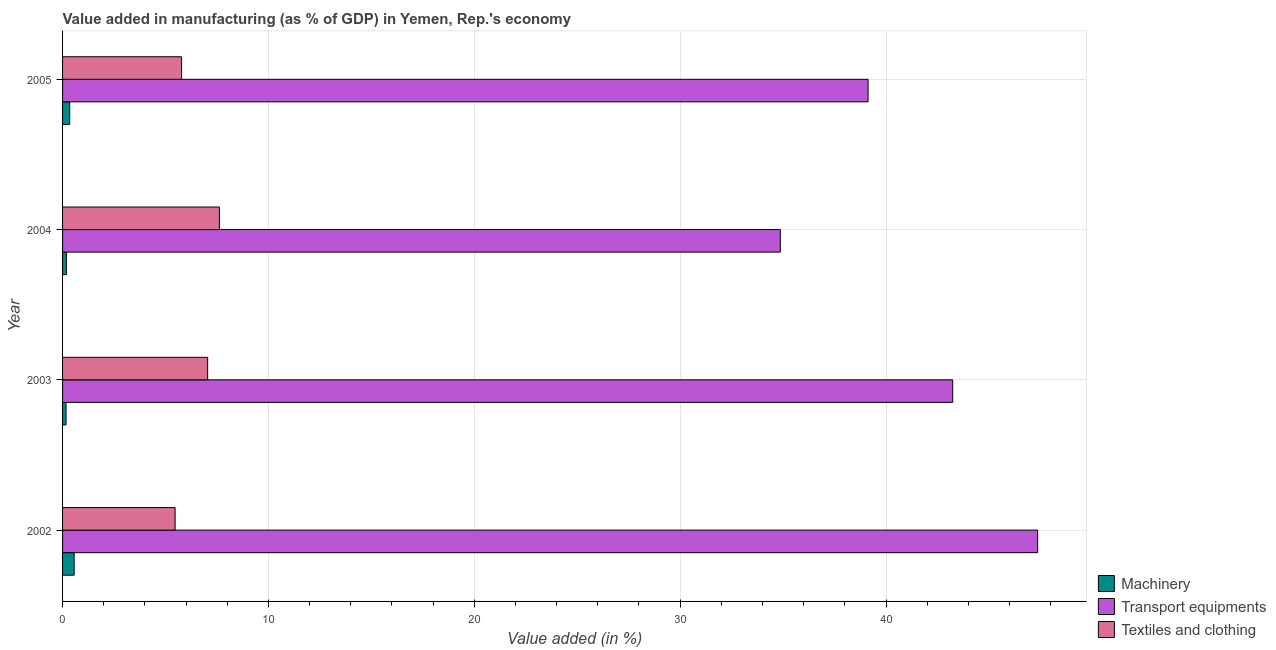Are the number of bars per tick equal to the number of legend labels?
Provide a short and direct response. Yes. How many bars are there on the 3rd tick from the bottom?
Keep it short and to the point. 3. What is the label of the 3rd group of bars from the top?
Offer a terse response. 2003. What is the value added in manufacturing machinery in 2005?
Ensure brevity in your answer.  0.35. Across all years, what is the maximum value added in manufacturing machinery?
Provide a short and direct response. 0.56. Across all years, what is the minimum value added in manufacturing textile and clothing?
Offer a terse response. 5.47. In which year was the value added in manufacturing machinery maximum?
Provide a succinct answer. 2002. In which year was the value added in manufacturing transport equipments minimum?
Keep it short and to the point. 2004. What is the total value added in manufacturing machinery in the graph?
Ensure brevity in your answer.  1.26. What is the difference between the value added in manufacturing textile and clothing in 2002 and that in 2005?
Your response must be concise. -0.31. What is the difference between the value added in manufacturing machinery in 2004 and the value added in manufacturing transport equipments in 2005?
Give a very brief answer. -38.94. What is the average value added in manufacturing machinery per year?
Ensure brevity in your answer.  0.32. In the year 2004, what is the difference between the value added in manufacturing transport equipments and value added in manufacturing machinery?
Ensure brevity in your answer.  34.68. In how many years, is the value added in manufacturing machinery greater than 8 %?
Offer a very short reply. 0. What is the ratio of the value added in manufacturing transport equipments in 2003 to that in 2005?
Make the answer very short. 1.1. Is the value added in manufacturing textile and clothing in 2002 less than that in 2003?
Give a very brief answer. Yes. What is the difference between the highest and the second highest value added in manufacturing machinery?
Your answer should be compact. 0.22. In how many years, is the value added in manufacturing machinery greater than the average value added in manufacturing machinery taken over all years?
Your response must be concise. 2. What does the 2nd bar from the top in 2005 represents?
Provide a succinct answer. Transport equipments. What does the 3rd bar from the bottom in 2004 represents?
Your response must be concise. Textiles and clothing. Is it the case that in every year, the sum of the value added in manufacturing machinery and value added in manufacturing transport equipments is greater than the value added in manufacturing textile and clothing?
Your response must be concise. Yes. How many bars are there?
Your answer should be very brief. 12. How many years are there in the graph?
Offer a very short reply. 4. What is the difference between two consecutive major ticks on the X-axis?
Your answer should be compact. 10. Does the graph contain any zero values?
Provide a succinct answer. No. Does the graph contain grids?
Make the answer very short. Yes. Where does the legend appear in the graph?
Offer a very short reply. Bottom right. What is the title of the graph?
Provide a succinct answer. Value added in manufacturing (as % of GDP) in Yemen, Rep.'s economy. Does "Secondary education" appear as one of the legend labels in the graph?
Offer a very short reply. No. What is the label or title of the X-axis?
Your answer should be compact. Value added (in %). What is the Value added (in %) in Machinery in 2002?
Provide a succinct answer. 0.56. What is the Value added (in %) of Transport equipments in 2002?
Keep it short and to the point. 47.36. What is the Value added (in %) in Textiles and clothing in 2002?
Your answer should be compact. 5.47. What is the Value added (in %) of Machinery in 2003?
Ensure brevity in your answer.  0.17. What is the Value added (in %) in Transport equipments in 2003?
Make the answer very short. 43.24. What is the Value added (in %) in Textiles and clothing in 2003?
Ensure brevity in your answer.  7.05. What is the Value added (in %) in Machinery in 2004?
Your answer should be very brief. 0.19. What is the Value added (in %) in Transport equipments in 2004?
Provide a short and direct response. 34.86. What is the Value added (in %) of Textiles and clothing in 2004?
Your answer should be very brief. 7.62. What is the Value added (in %) of Machinery in 2005?
Provide a short and direct response. 0.35. What is the Value added (in %) of Transport equipments in 2005?
Make the answer very short. 39.13. What is the Value added (in %) in Textiles and clothing in 2005?
Offer a terse response. 5.78. Across all years, what is the maximum Value added (in %) of Machinery?
Your answer should be compact. 0.56. Across all years, what is the maximum Value added (in %) in Transport equipments?
Offer a very short reply. 47.36. Across all years, what is the maximum Value added (in %) in Textiles and clothing?
Your answer should be very brief. 7.62. Across all years, what is the minimum Value added (in %) in Machinery?
Provide a succinct answer. 0.17. Across all years, what is the minimum Value added (in %) of Transport equipments?
Make the answer very short. 34.86. Across all years, what is the minimum Value added (in %) of Textiles and clothing?
Your answer should be very brief. 5.47. What is the total Value added (in %) in Machinery in the graph?
Give a very brief answer. 1.26. What is the total Value added (in %) of Transport equipments in the graph?
Offer a very short reply. 164.59. What is the total Value added (in %) of Textiles and clothing in the graph?
Ensure brevity in your answer.  25.91. What is the difference between the Value added (in %) of Machinery in 2002 and that in 2003?
Your answer should be compact. 0.39. What is the difference between the Value added (in %) in Transport equipments in 2002 and that in 2003?
Your response must be concise. 4.12. What is the difference between the Value added (in %) in Textiles and clothing in 2002 and that in 2003?
Ensure brevity in your answer.  -1.58. What is the difference between the Value added (in %) of Machinery in 2002 and that in 2004?
Ensure brevity in your answer.  0.38. What is the difference between the Value added (in %) of Transport equipments in 2002 and that in 2004?
Make the answer very short. 12.5. What is the difference between the Value added (in %) of Textiles and clothing in 2002 and that in 2004?
Offer a very short reply. -2.15. What is the difference between the Value added (in %) of Machinery in 2002 and that in 2005?
Your answer should be very brief. 0.22. What is the difference between the Value added (in %) of Transport equipments in 2002 and that in 2005?
Make the answer very short. 8.24. What is the difference between the Value added (in %) of Textiles and clothing in 2002 and that in 2005?
Your answer should be very brief. -0.31. What is the difference between the Value added (in %) in Machinery in 2003 and that in 2004?
Provide a short and direct response. -0.02. What is the difference between the Value added (in %) in Transport equipments in 2003 and that in 2004?
Your answer should be compact. 8.37. What is the difference between the Value added (in %) in Textiles and clothing in 2003 and that in 2004?
Your answer should be very brief. -0.57. What is the difference between the Value added (in %) of Machinery in 2003 and that in 2005?
Keep it short and to the point. -0.18. What is the difference between the Value added (in %) of Transport equipments in 2003 and that in 2005?
Give a very brief answer. 4.11. What is the difference between the Value added (in %) of Textiles and clothing in 2003 and that in 2005?
Ensure brevity in your answer.  1.27. What is the difference between the Value added (in %) of Machinery in 2004 and that in 2005?
Give a very brief answer. -0.16. What is the difference between the Value added (in %) in Transport equipments in 2004 and that in 2005?
Your response must be concise. -4.26. What is the difference between the Value added (in %) of Textiles and clothing in 2004 and that in 2005?
Your answer should be very brief. 1.84. What is the difference between the Value added (in %) in Machinery in 2002 and the Value added (in %) in Transport equipments in 2003?
Provide a short and direct response. -42.68. What is the difference between the Value added (in %) of Machinery in 2002 and the Value added (in %) of Textiles and clothing in 2003?
Provide a succinct answer. -6.49. What is the difference between the Value added (in %) of Transport equipments in 2002 and the Value added (in %) of Textiles and clothing in 2003?
Keep it short and to the point. 40.31. What is the difference between the Value added (in %) of Machinery in 2002 and the Value added (in %) of Transport equipments in 2004?
Offer a terse response. -34.3. What is the difference between the Value added (in %) of Machinery in 2002 and the Value added (in %) of Textiles and clothing in 2004?
Your answer should be very brief. -7.05. What is the difference between the Value added (in %) of Transport equipments in 2002 and the Value added (in %) of Textiles and clothing in 2004?
Give a very brief answer. 39.75. What is the difference between the Value added (in %) in Machinery in 2002 and the Value added (in %) in Transport equipments in 2005?
Make the answer very short. -38.56. What is the difference between the Value added (in %) in Machinery in 2002 and the Value added (in %) in Textiles and clothing in 2005?
Make the answer very short. -5.22. What is the difference between the Value added (in %) in Transport equipments in 2002 and the Value added (in %) in Textiles and clothing in 2005?
Provide a succinct answer. 41.58. What is the difference between the Value added (in %) of Machinery in 2003 and the Value added (in %) of Transport equipments in 2004?
Make the answer very short. -34.7. What is the difference between the Value added (in %) of Machinery in 2003 and the Value added (in %) of Textiles and clothing in 2004?
Offer a very short reply. -7.45. What is the difference between the Value added (in %) in Transport equipments in 2003 and the Value added (in %) in Textiles and clothing in 2004?
Make the answer very short. 35.62. What is the difference between the Value added (in %) of Machinery in 2003 and the Value added (in %) of Transport equipments in 2005?
Your response must be concise. -38.96. What is the difference between the Value added (in %) in Machinery in 2003 and the Value added (in %) in Textiles and clothing in 2005?
Keep it short and to the point. -5.61. What is the difference between the Value added (in %) in Transport equipments in 2003 and the Value added (in %) in Textiles and clothing in 2005?
Offer a very short reply. 37.46. What is the difference between the Value added (in %) in Machinery in 2004 and the Value added (in %) in Transport equipments in 2005?
Keep it short and to the point. -38.94. What is the difference between the Value added (in %) in Machinery in 2004 and the Value added (in %) in Textiles and clothing in 2005?
Offer a very short reply. -5.59. What is the difference between the Value added (in %) of Transport equipments in 2004 and the Value added (in %) of Textiles and clothing in 2005?
Offer a terse response. 29.08. What is the average Value added (in %) of Machinery per year?
Offer a very short reply. 0.32. What is the average Value added (in %) of Transport equipments per year?
Give a very brief answer. 41.15. What is the average Value added (in %) in Textiles and clothing per year?
Offer a very short reply. 6.48. In the year 2002, what is the difference between the Value added (in %) of Machinery and Value added (in %) of Transport equipments?
Give a very brief answer. -46.8. In the year 2002, what is the difference between the Value added (in %) of Machinery and Value added (in %) of Textiles and clothing?
Your response must be concise. -4.9. In the year 2002, what is the difference between the Value added (in %) of Transport equipments and Value added (in %) of Textiles and clothing?
Provide a short and direct response. 41.9. In the year 2003, what is the difference between the Value added (in %) in Machinery and Value added (in %) in Transport equipments?
Your response must be concise. -43.07. In the year 2003, what is the difference between the Value added (in %) of Machinery and Value added (in %) of Textiles and clothing?
Your answer should be very brief. -6.88. In the year 2003, what is the difference between the Value added (in %) of Transport equipments and Value added (in %) of Textiles and clothing?
Give a very brief answer. 36.19. In the year 2004, what is the difference between the Value added (in %) of Machinery and Value added (in %) of Transport equipments?
Give a very brief answer. -34.68. In the year 2004, what is the difference between the Value added (in %) of Machinery and Value added (in %) of Textiles and clothing?
Your response must be concise. -7.43. In the year 2004, what is the difference between the Value added (in %) of Transport equipments and Value added (in %) of Textiles and clothing?
Your answer should be compact. 27.25. In the year 2005, what is the difference between the Value added (in %) of Machinery and Value added (in %) of Transport equipments?
Your answer should be very brief. -38.78. In the year 2005, what is the difference between the Value added (in %) of Machinery and Value added (in %) of Textiles and clothing?
Your answer should be compact. -5.43. In the year 2005, what is the difference between the Value added (in %) in Transport equipments and Value added (in %) in Textiles and clothing?
Ensure brevity in your answer.  33.35. What is the ratio of the Value added (in %) in Machinery in 2002 to that in 2003?
Your response must be concise. 3.32. What is the ratio of the Value added (in %) in Transport equipments in 2002 to that in 2003?
Your response must be concise. 1.1. What is the ratio of the Value added (in %) in Textiles and clothing in 2002 to that in 2003?
Keep it short and to the point. 0.78. What is the ratio of the Value added (in %) of Machinery in 2002 to that in 2004?
Your response must be concise. 3.02. What is the ratio of the Value added (in %) in Transport equipments in 2002 to that in 2004?
Your answer should be very brief. 1.36. What is the ratio of the Value added (in %) in Textiles and clothing in 2002 to that in 2004?
Your answer should be compact. 0.72. What is the ratio of the Value added (in %) in Machinery in 2002 to that in 2005?
Make the answer very short. 1.62. What is the ratio of the Value added (in %) of Transport equipments in 2002 to that in 2005?
Keep it short and to the point. 1.21. What is the ratio of the Value added (in %) of Textiles and clothing in 2002 to that in 2005?
Your answer should be compact. 0.95. What is the ratio of the Value added (in %) in Machinery in 2003 to that in 2004?
Your answer should be compact. 0.91. What is the ratio of the Value added (in %) of Transport equipments in 2003 to that in 2004?
Your answer should be very brief. 1.24. What is the ratio of the Value added (in %) in Textiles and clothing in 2003 to that in 2004?
Ensure brevity in your answer.  0.93. What is the ratio of the Value added (in %) in Machinery in 2003 to that in 2005?
Provide a short and direct response. 0.49. What is the ratio of the Value added (in %) of Transport equipments in 2003 to that in 2005?
Make the answer very short. 1.11. What is the ratio of the Value added (in %) in Textiles and clothing in 2003 to that in 2005?
Ensure brevity in your answer.  1.22. What is the ratio of the Value added (in %) in Machinery in 2004 to that in 2005?
Your response must be concise. 0.54. What is the ratio of the Value added (in %) of Transport equipments in 2004 to that in 2005?
Offer a very short reply. 0.89. What is the ratio of the Value added (in %) of Textiles and clothing in 2004 to that in 2005?
Give a very brief answer. 1.32. What is the difference between the highest and the second highest Value added (in %) in Machinery?
Offer a very short reply. 0.22. What is the difference between the highest and the second highest Value added (in %) in Transport equipments?
Offer a very short reply. 4.12. What is the difference between the highest and the second highest Value added (in %) of Textiles and clothing?
Your answer should be very brief. 0.57. What is the difference between the highest and the lowest Value added (in %) of Machinery?
Your answer should be very brief. 0.39. What is the difference between the highest and the lowest Value added (in %) in Transport equipments?
Offer a terse response. 12.5. What is the difference between the highest and the lowest Value added (in %) in Textiles and clothing?
Provide a succinct answer. 2.15. 